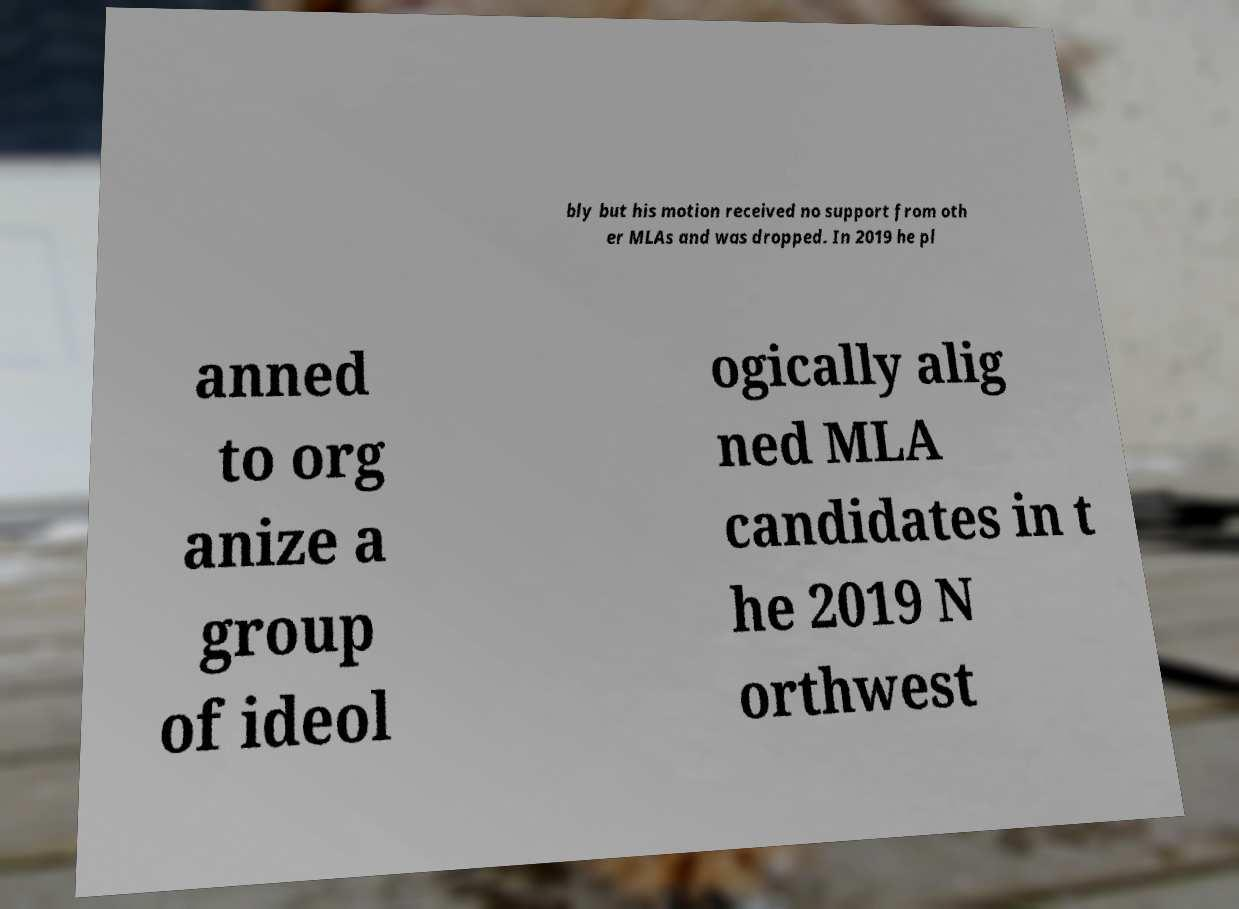Could you assist in decoding the text presented in this image and type it out clearly? bly but his motion received no support from oth er MLAs and was dropped. In 2019 he pl anned to org anize a group of ideol ogically alig ned MLA candidates in t he 2019 N orthwest 